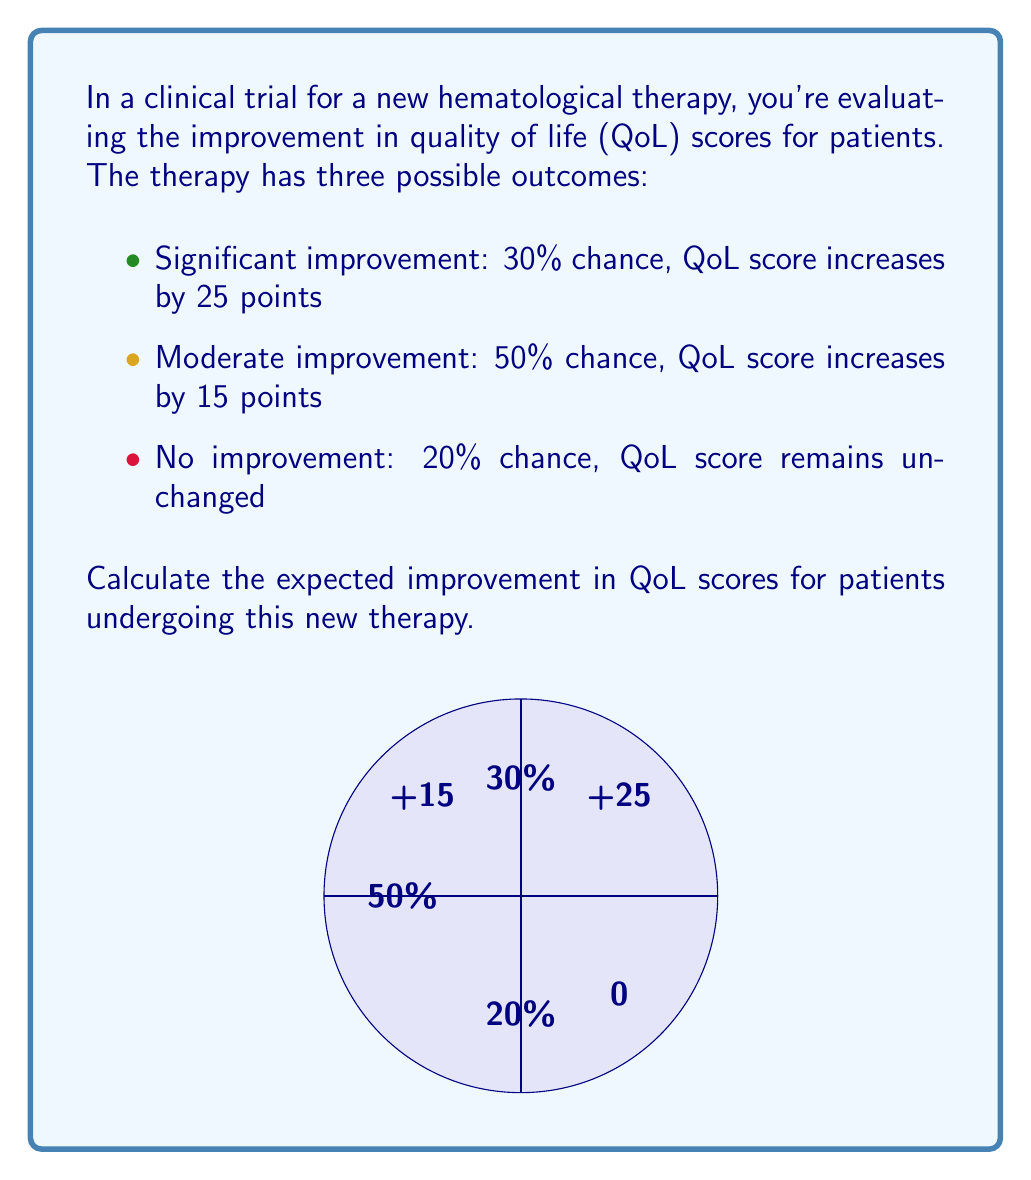Provide a solution to this math problem. To calculate the expected improvement in QoL scores, we need to use the concept of expected value. The expected value is the sum of each possible outcome multiplied by its probability.

Let's break it down step-by-step:

1) For significant improvement:
   Probability = 30% = 0.30
   QoL score increase = 25 points
   Expected value = $0.30 \times 25 = 7.5$ points

2) For moderate improvement:
   Probability = 50% = 0.50
   QoL score increase = 15 points
   Expected value = $0.50 \times 15 = 7.5$ points

3) For no improvement:
   Probability = 20% = 0.20
   QoL score increase = 0 points
   Expected value = $0.20 \times 0 = 0$ points

Now, we sum these expected values:

$$\text{Expected Improvement} = 7.5 + 7.5 + 0 = 15\text{ points}$$

This can also be expressed in a single formula:

$$E(\text{Improvement}) = 0.30 \times 25 + 0.50 \times 15 + 0.20 \times 0 = 15$$

Therefore, the expected improvement in QoL scores for patients undergoing this new therapy is 15 points.
Answer: 15 points 